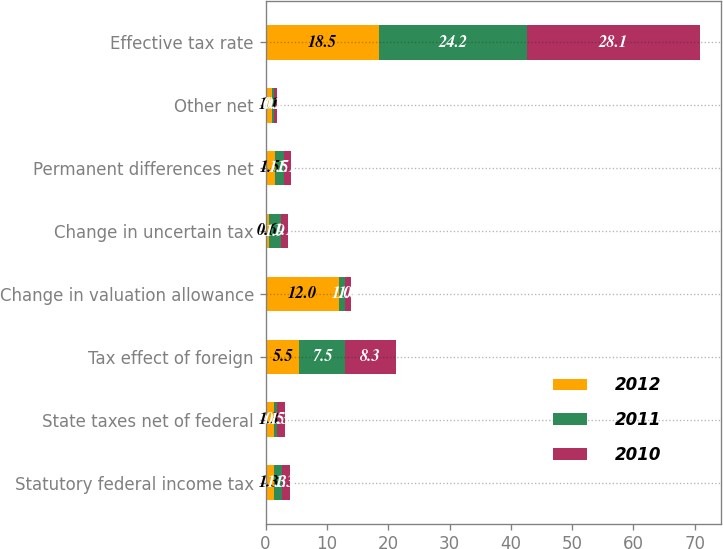Convert chart. <chart><loc_0><loc_0><loc_500><loc_500><stacked_bar_chart><ecel><fcel>Statutory federal income tax<fcel>State taxes net of federal<fcel>Tax effect of foreign<fcel>Change in valuation allowance<fcel>Change in uncertain tax<fcel>Permanent differences net<fcel>Other net<fcel>Effective tax rate<nl><fcel>2012<fcel>1.3<fcel>1.3<fcel>5.5<fcel>12<fcel>0.6<fcel>1.5<fcel>1.1<fcel>18.5<nl><fcel>2011<fcel>1.3<fcel>0.5<fcel>7.5<fcel>1<fcel>1.9<fcel>1.5<fcel>0.2<fcel>24.2<nl><fcel>2010<fcel>1.3<fcel>1.3<fcel>8.3<fcel>1<fcel>1.1<fcel>1.1<fcel>0.5<fcel>28.1<nl></chart> 